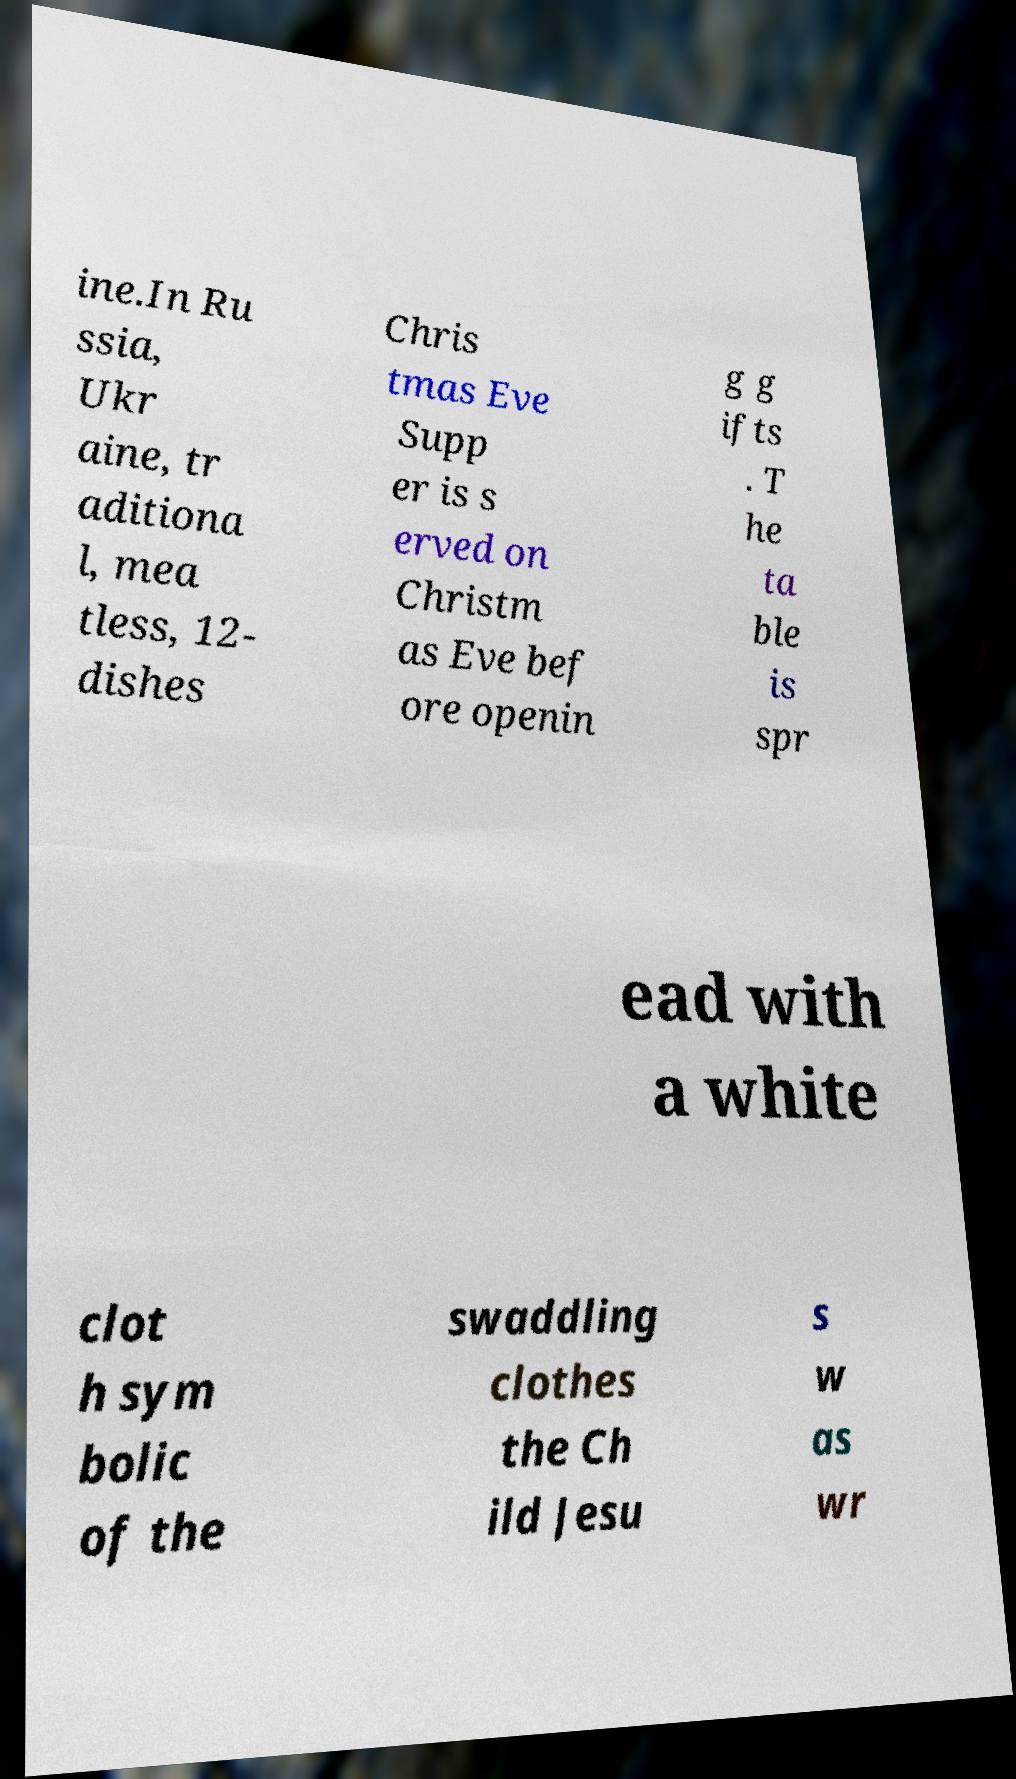Can you read and provide the text displayed in the image?This photo seems to have some interesting text. Can you extract and type it out for me? ine.In Ru ssia, Ukr aine, tr aditiona l, mea tless, 12- dishes Chris tmas Eve Supp er is s erved on Christm as Eve bef ore openin g g ifts . T he ta ble is spr ead with a white clot h sym bolic of the swaddling clothes the Ch ild Jesu s w as wr 